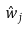<formula> <loc_0><loc_0><loc_500><loc_500>\hat { w } _ { j }</formula> 